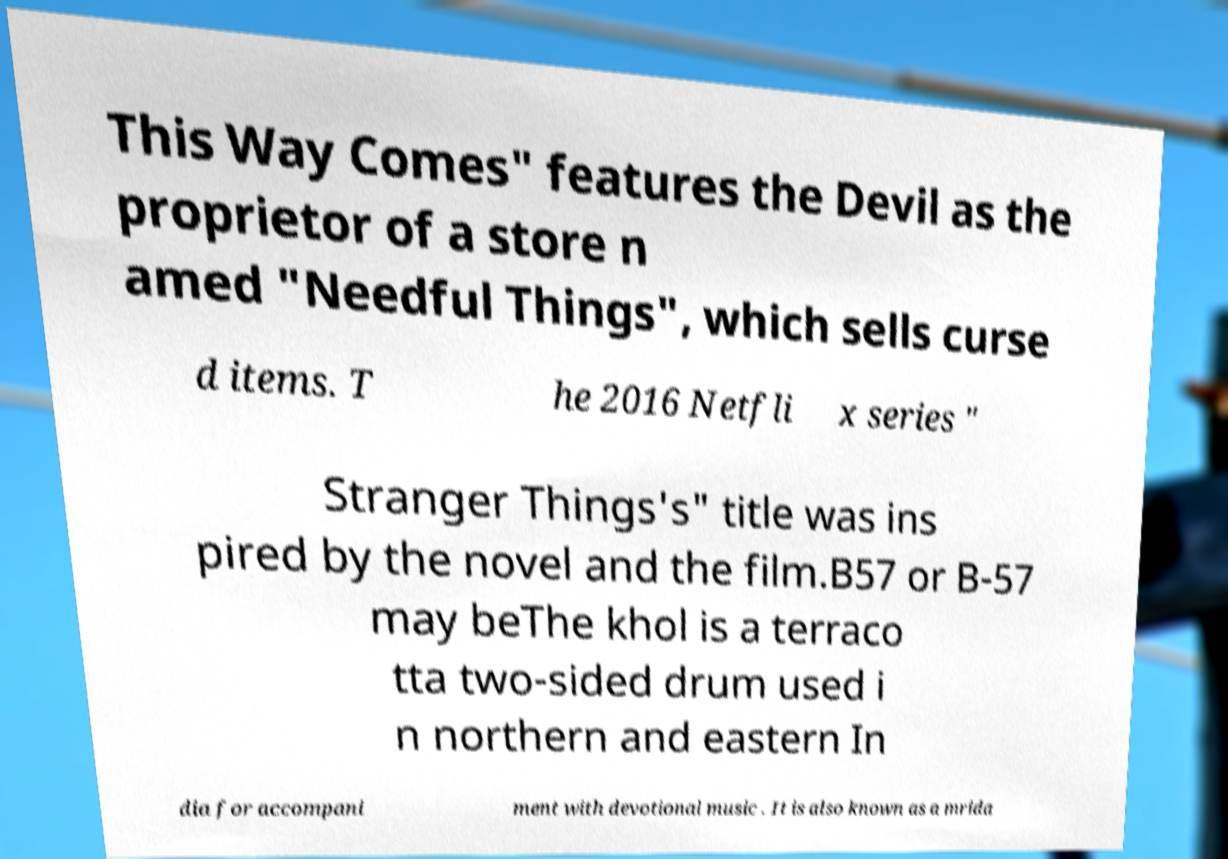Could you extract and type out the text from this image? This Way Comes" features the Devil as the proprietor of a store n amed "Needful Things", which sells curse d items. T he 2016 Netfli x series " Stranger Things's" title was ins pired by the novel and the film.B57 or B-57 may beThe khol is a terraco tta two-sided drum used i n northern and eastern In dia for accompani ment with devotional music . It is also known as a mrida 